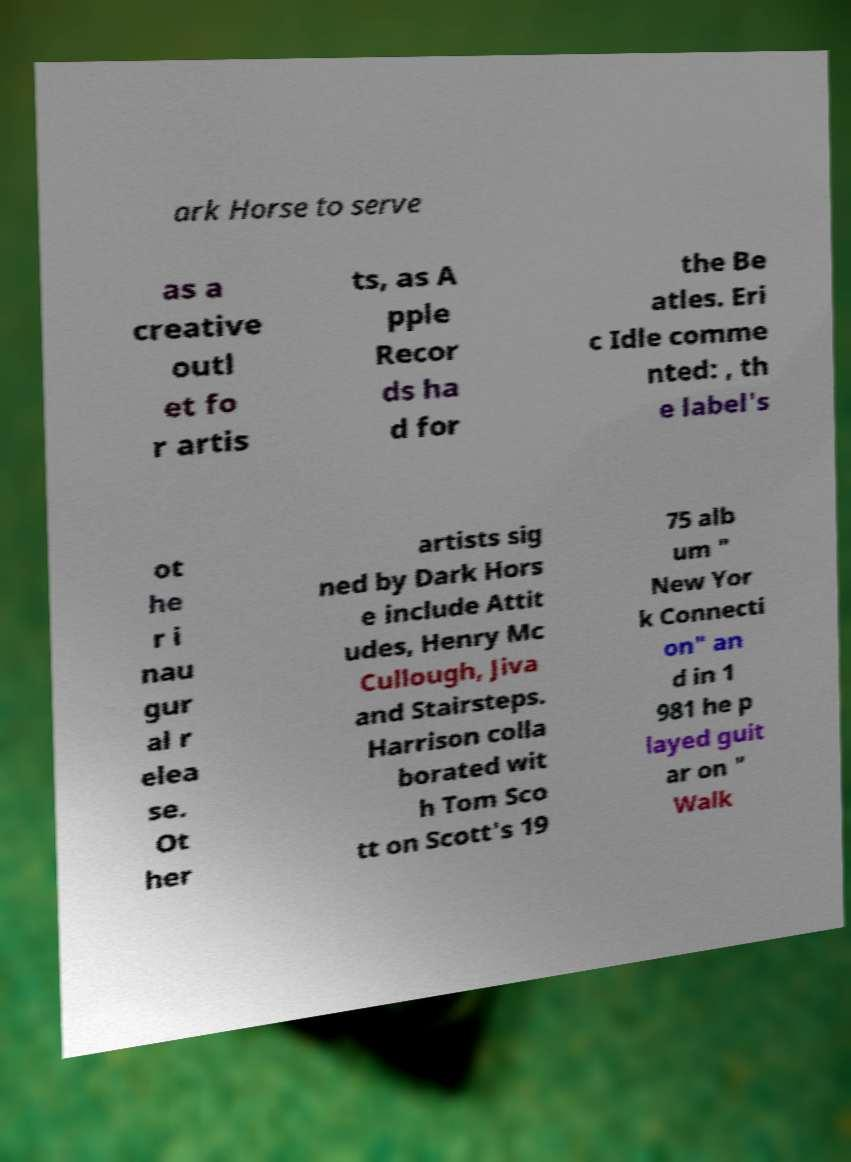Can you read and provide the text displayed in the image?This photo seems to have some interesting text. Can you extract and type it out for me? ark Horse to serve as a creative outl et fo r artis ts, as A pple Recor ds ha d for the Be atles. Eri c Idle comme nted: , th e label's ot he r i nau gur al r elea se. Ot her artists sig ned by Dark Hors e include Attit udes, Henry Mc Cullough, Jiva and Stairsteps. Harrison colla borated wit h Tom Sco tt on Scott's 19 75 alb um " New Yor k Connecti on" an d in 1 981 he p layed guit ar on " Walk 